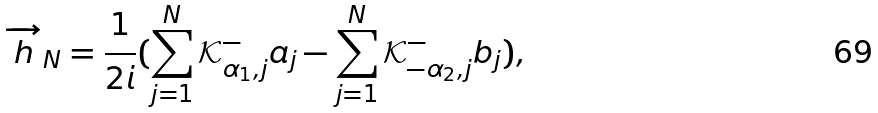Convert formula to latex. <formula><loc_0><loc_0><loc_500><loc_500>\overrightarrow { h } _ { N } = \frac { 1 } { 2 i } ( \sum _ { j = 1 } ^ { N } \mathcal { K } _ { \alpha _ { 1 } , j } ^ { - } a _ { j } - \sum _ { j = 1 } ^ { N } \mathcal { K } _ { - \alpha _ { 2 } , j } ^ { - } b _ { j } ) ,</formula> 